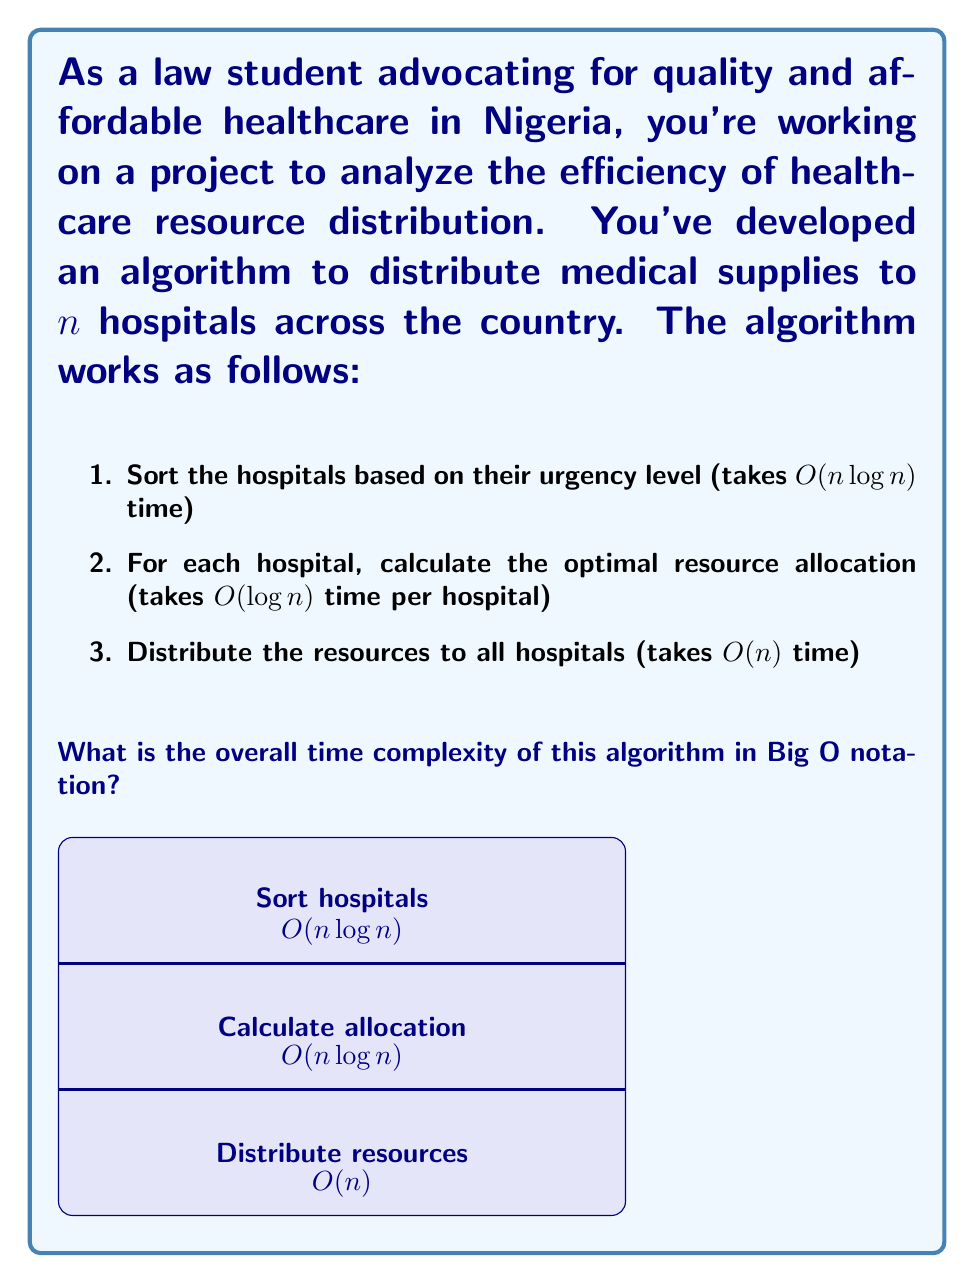Give your solution to this math problem. To determine the overall time complexity, we need to analyze each step of the algorithm and combine them:

1. Sorting the hospitals: $O(n \log n)$
   This is typically the time complexity for efficient sorting algorithms like Merge Sort or Heap Sort.

2. Calculating optimal resource allocation: $O(n \log n)$
   For each of the $n$ hospitals, we perform a calculation that takes $O(\log n)$ time.
   So, the total time for this step is $O(n) * O(\log n) = O(n \log n)$

3. Distributing resources: $O(n)$
   This step involves a single pass through all $n$ hospitals.

Now, we need to combine these complexities. In algorithm analysis, we add the complexities of sequential steps and take the maximum of nested steps. Here, all steps are sequential, so we add them:

$$O(n \log n) + O(n \log n) + O(n)$$

Simplifying:
$$O(n \log n) + O(n \log n) + O(n) = O(2n \log n + n)$$

In Big O notation, we drop constant factors and lower order terms. Therefore:

$$O(2n \log n + n) = O(n \log n)$$

This simplification is valid because $n \log n$ grows faster than $n$ for large values of $n$, and the constant factor 2 is not significant in Big O notation.
Answer: $O(n \log n)$ 